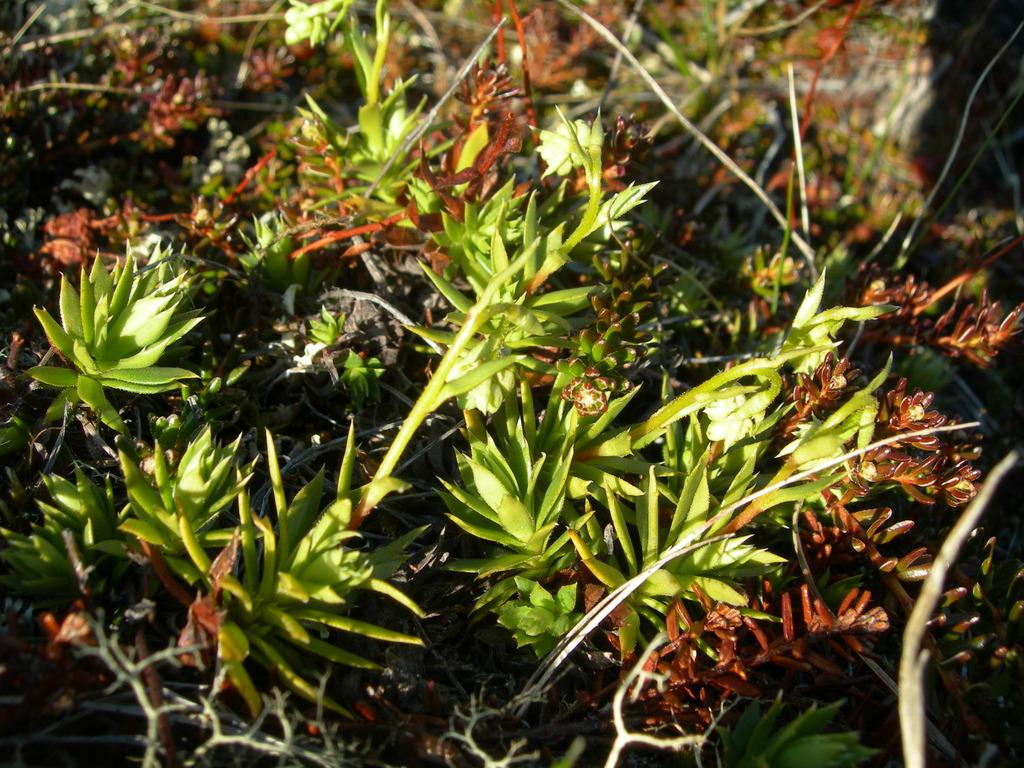What type of living organisms can be seen in the image? Plants can be seen in the image. What part of the plants is visible in the image? Leaves are visible in the image. What type of shock can be seen affecting the plants in the image? There is no shock present in the image; the plants and leaves appear to be in a natural state. 